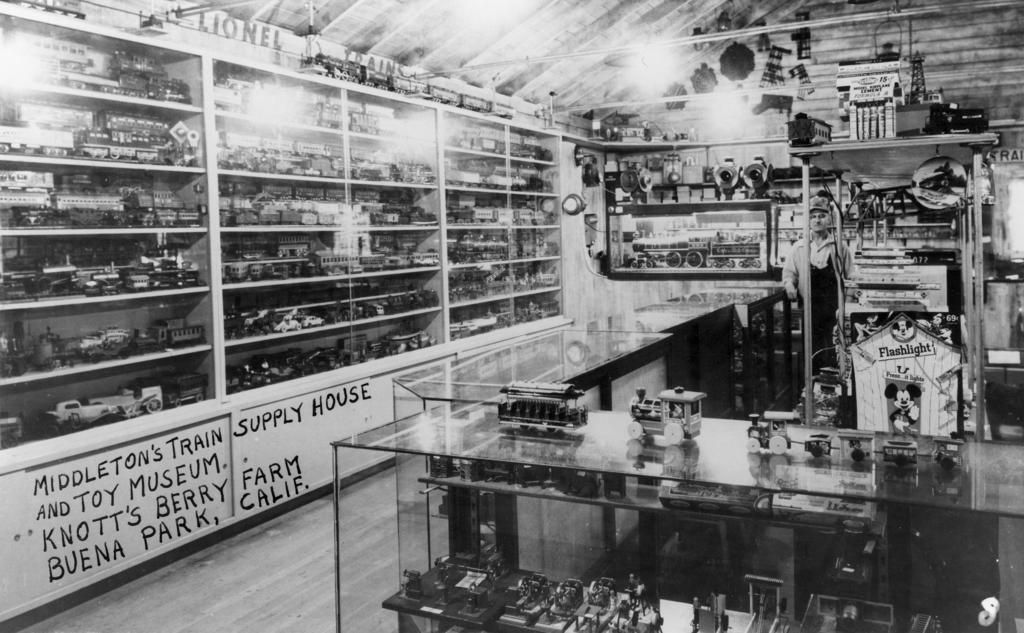<image>
Render a clear and concise summary of the photo. A room with the writing that says Middleton's Train Supply House 